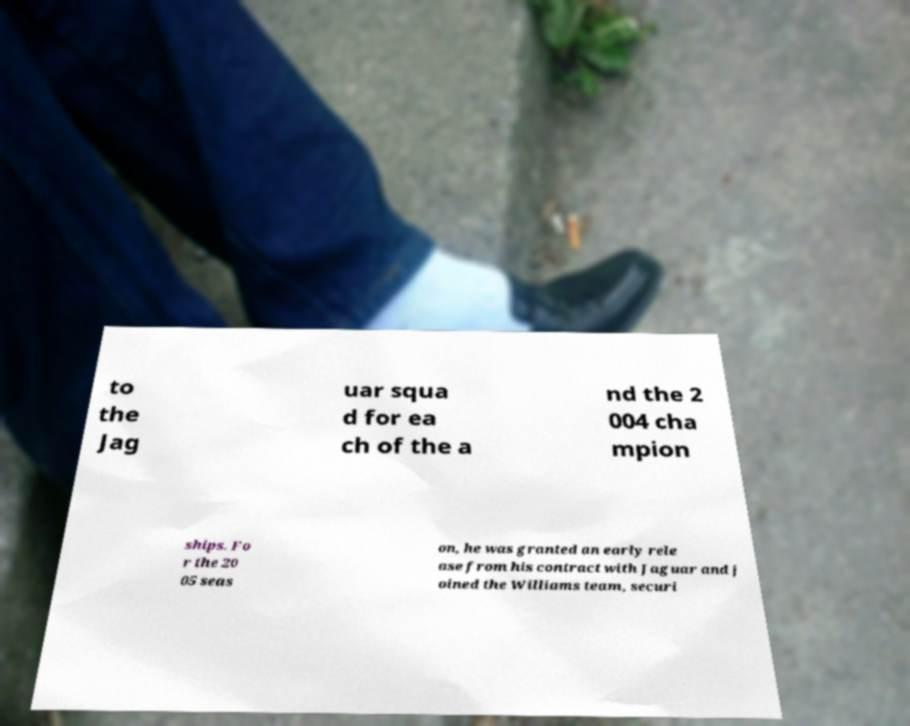I need the written content from this picture converted into text. Can you do that? to the Jag uar squa d for ea ch of the a nd the 2 004 cha mpion ships. Fo r the 20 05 seas on, he was granted an early rele ase from his contract with Jaguar and j oined the Williams team, securi 